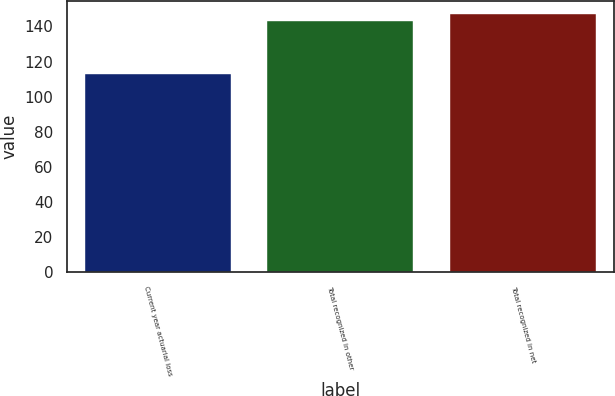Convert chart to OTSL. <chart><loc_0><loc_0><loc_500><loc_500><bar_chart><fcel>Current year actuarial loss<fcel>Total recognized in other<fcel>Total recognized in net<nl><fcel>113<fcel>143<fcel>147<nl></chart> 